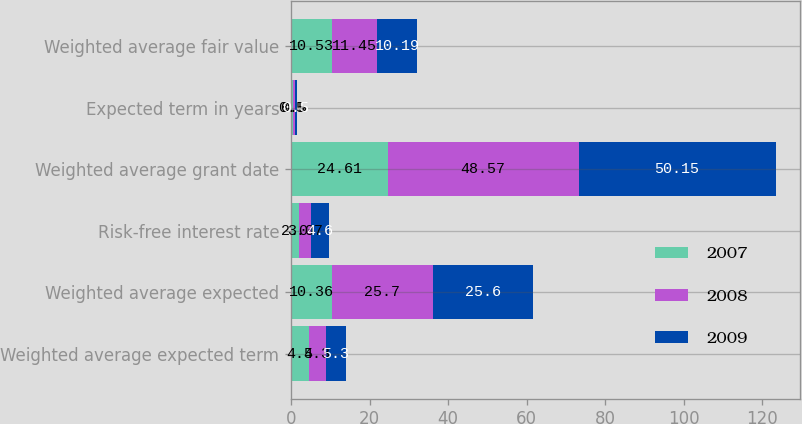Convert chart. <chart><loc_0><loc_0><loc_500><loc_500><stacked_bar_chart><ecel><fcel>Weighted average expected term<fcel>Weighted average expected<fcel>Risk-free interest rate<fcel>Weighted average grant date<fcel>Expected term in years<fcel>Weighted average fair value<nl><fcel>2007<fcel>4.5<fcel>10.36<fcel>2<fcel>24.61<fcel>0.5<fcel>10.53<nl><fcel>2008<fcel>4.3<fcel>25.7<fcel>3.07<fcel>48.57<fcel>0.5<fcel>11.45<nl><fcel>2009<fcel>5.3<fcel>25.6<fcel>4.6<fcel>50.15<fcel>0.5<fcel>10.19<nl></chart> 